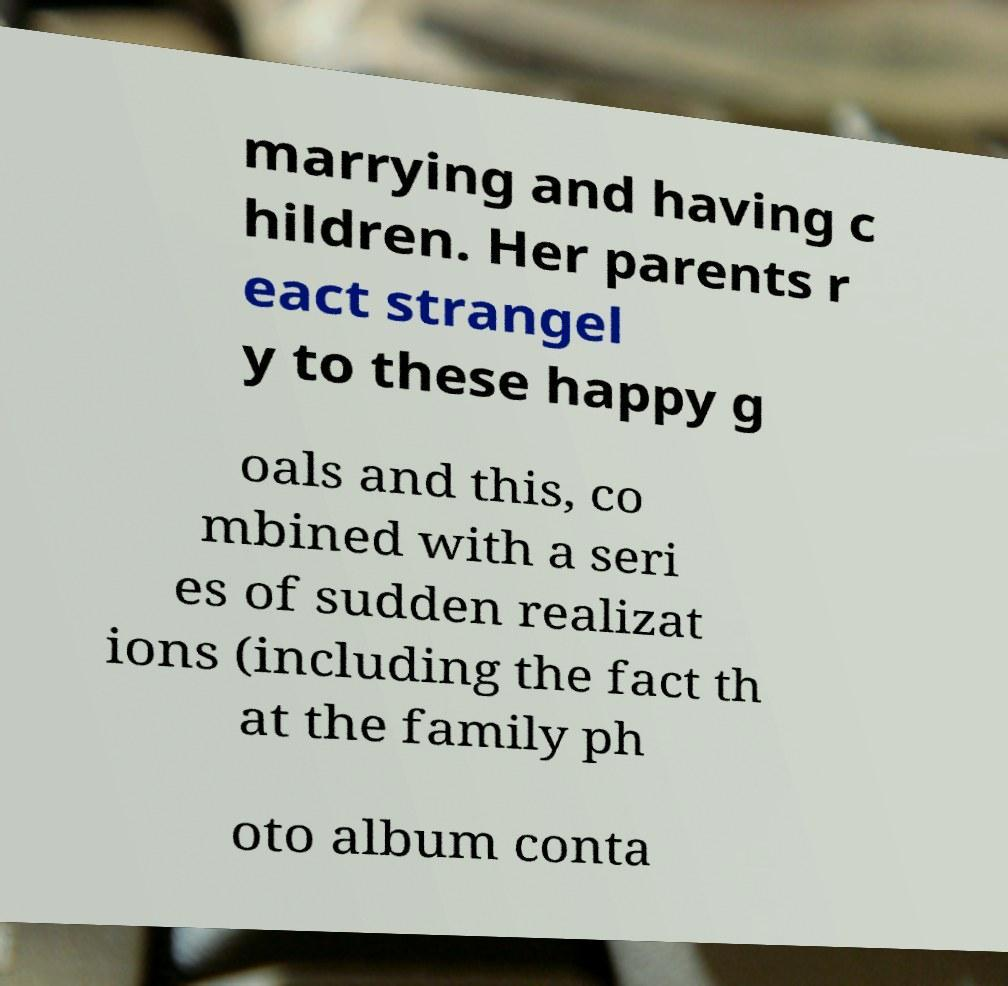Can you read and provide the text displayed in the image?This photo seems to have some interesting text. Can you extract and type it out for me? marrying and having c hildren. Her parents r eact strangel y to these happy g oals and this, co mbined with a seri es of sudden realizat ions (including the fact th at the family ph oto album conta 